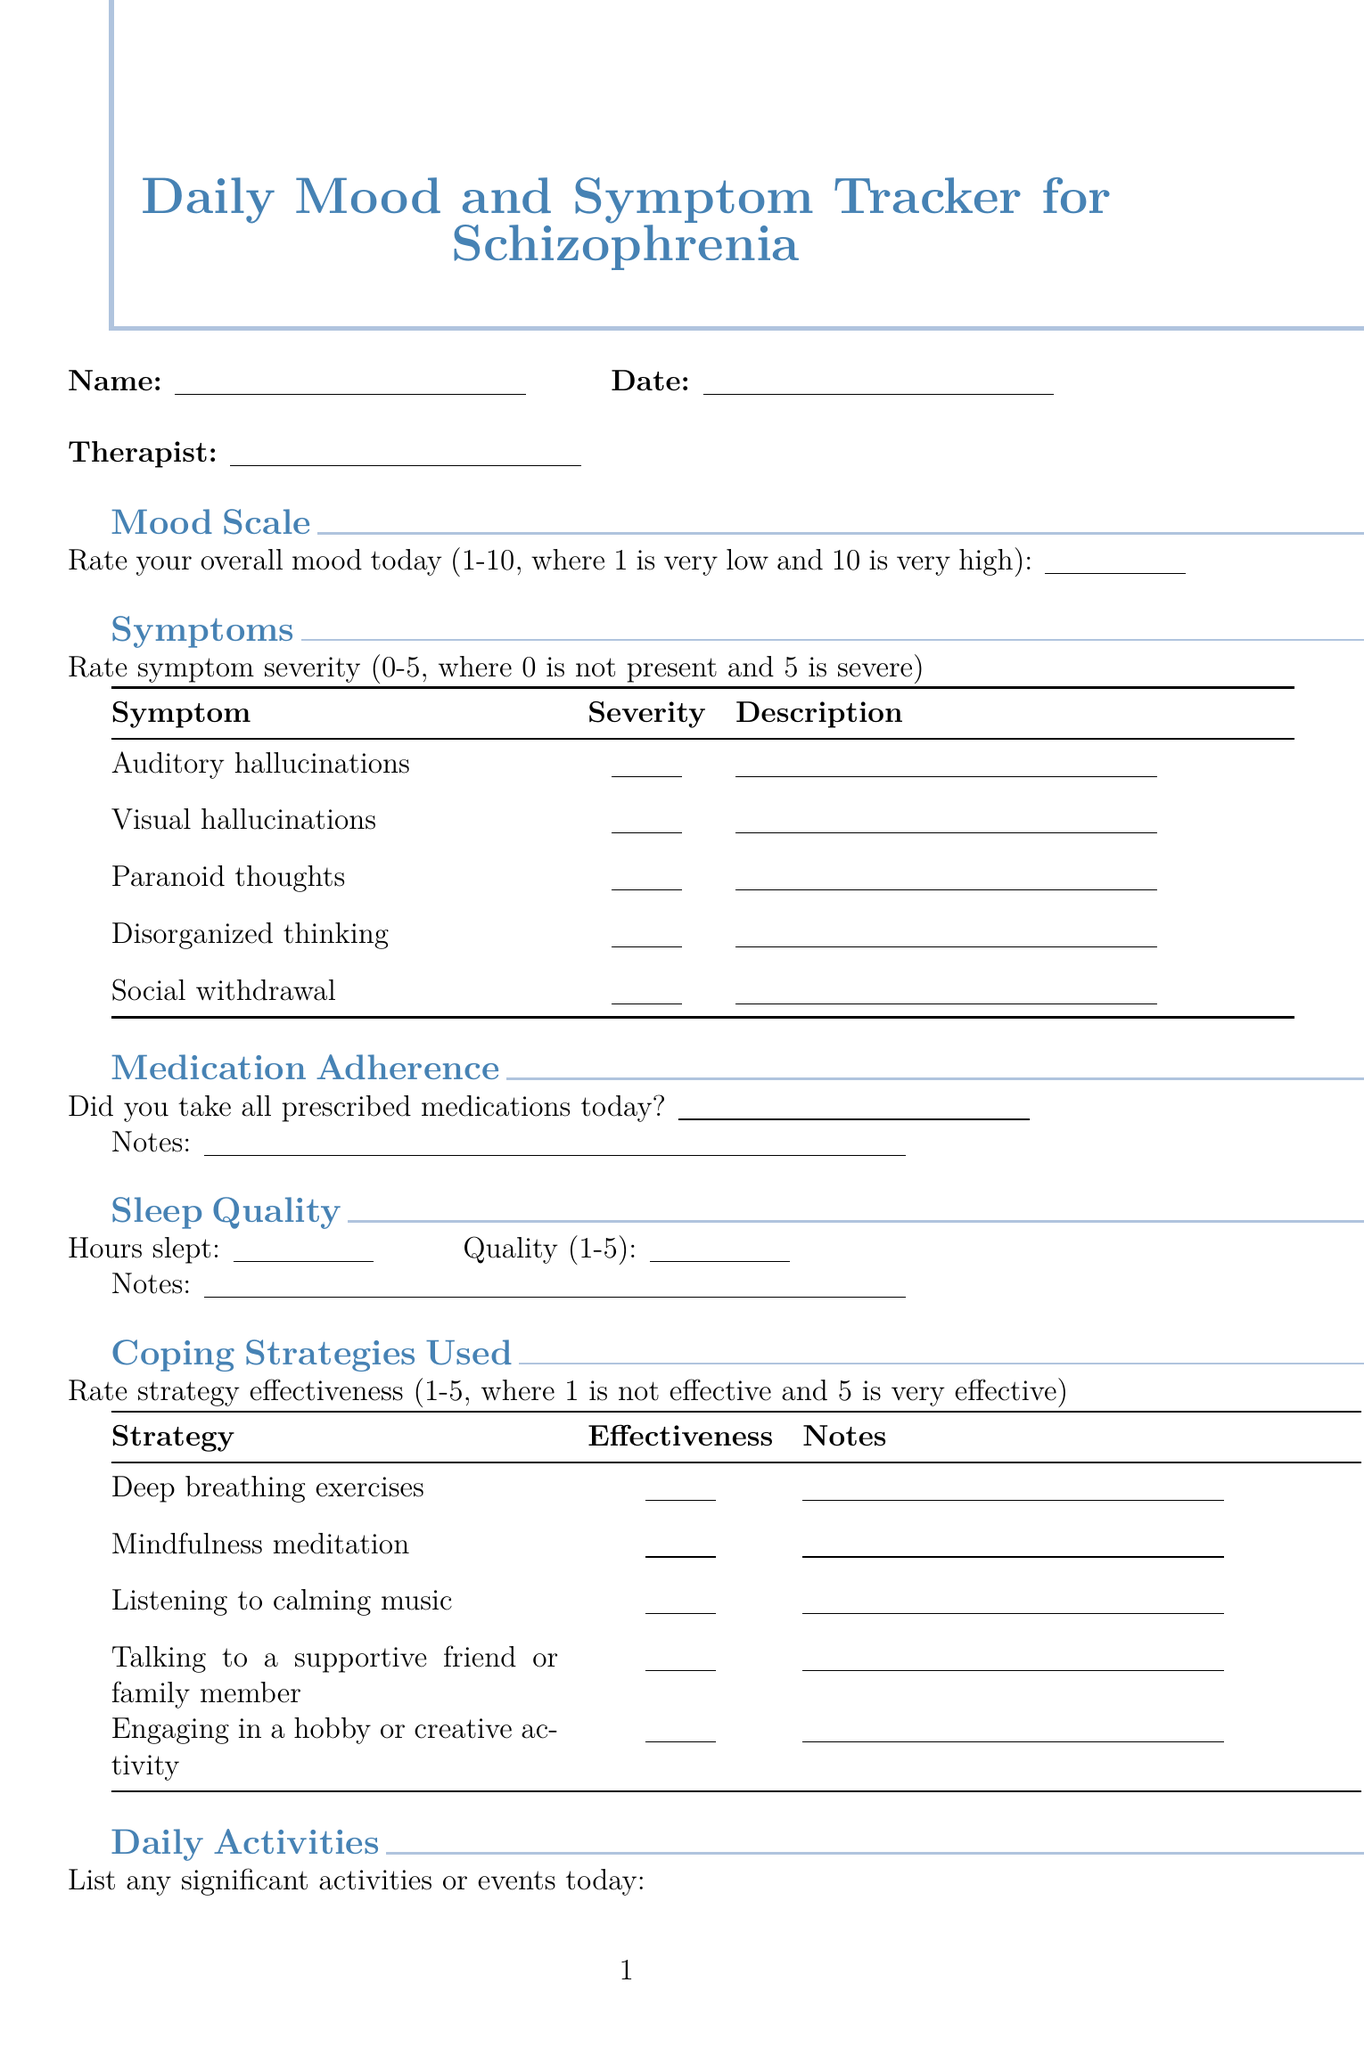What is the title of the document? The title of the document is stated at the top of the form.
Answer: Daily Mood and Symptom Tracker for Schizophrenia Who is the psychiatrist listed as an emergency contact? The document provides a name and role for emergency contacts.
Answer: Dr. Sarah Johnson What is the mood scale rating range? The mood scale rating is defined within the document's description.
Answer: 1-10 How many coping strategies are provided in the form? The number of coping strategies is evident from the list in the coping strategies section.
Answer: Five What is the response format for sleep quality? The document specifies a format for inputting sleep quality, indicating two components.
Answer: Hours and quality What is the severity rating scale for symptoms? The document describes how to rate symptom severity.
Answer: 0-5 What is noted under positive experiences? The section invites notes regarding any positive experiences.
Answer: Positive experiences or accomplishments What should be listed for daily activities? The section indicates that significant events or activities need to be noted.
Answer: Significant activities or events What is the effectiveness scale for coping strategies? The effectiveness scale is described in terms of its rating range.
Answer: 1-5 